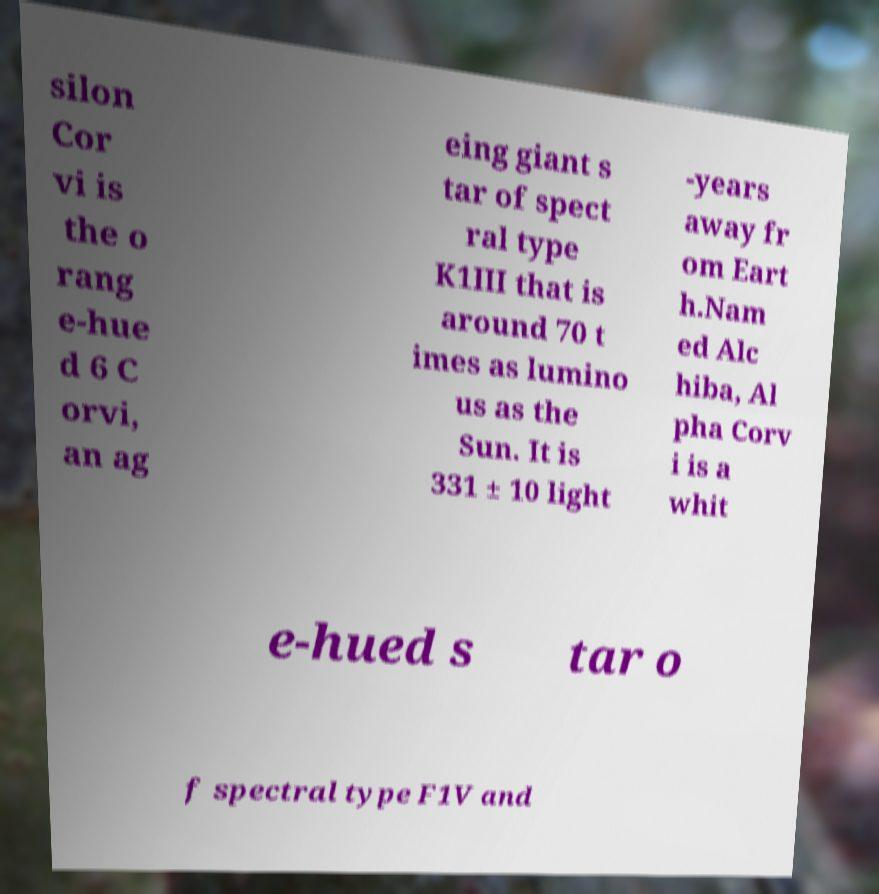Could you extract and type out the text from this image? silon Cor vi is the o rang e-hue d 6 C orvi, an ag eing giant s tar of spect ral type K1III that is around 70 t imes as lumino us as the Sun. It is 331 ± 10 light -years away fr om Eart h.Nam ed Alc hiba, Al pha Corv i is a whit e-hued s tar o f spectral type F1V and 